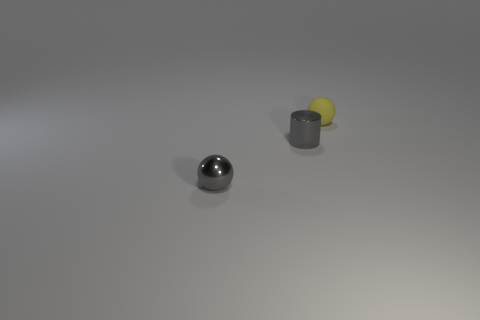Add 3 shiny cubes. How many objects exist? 6 Subtract all cylinders. How many objects are left? 2 Subtract all tiny yellow rubber cylinders. Subtract all yellow matte balls. How many objects are left? 2 Add 2 tiny rubber spheres. How many tiny rubber spheres are left? 3 Add 2 cylinders. How many cylinders exist? 3 Subtract 0 red cubes. How many objects are left? 3 